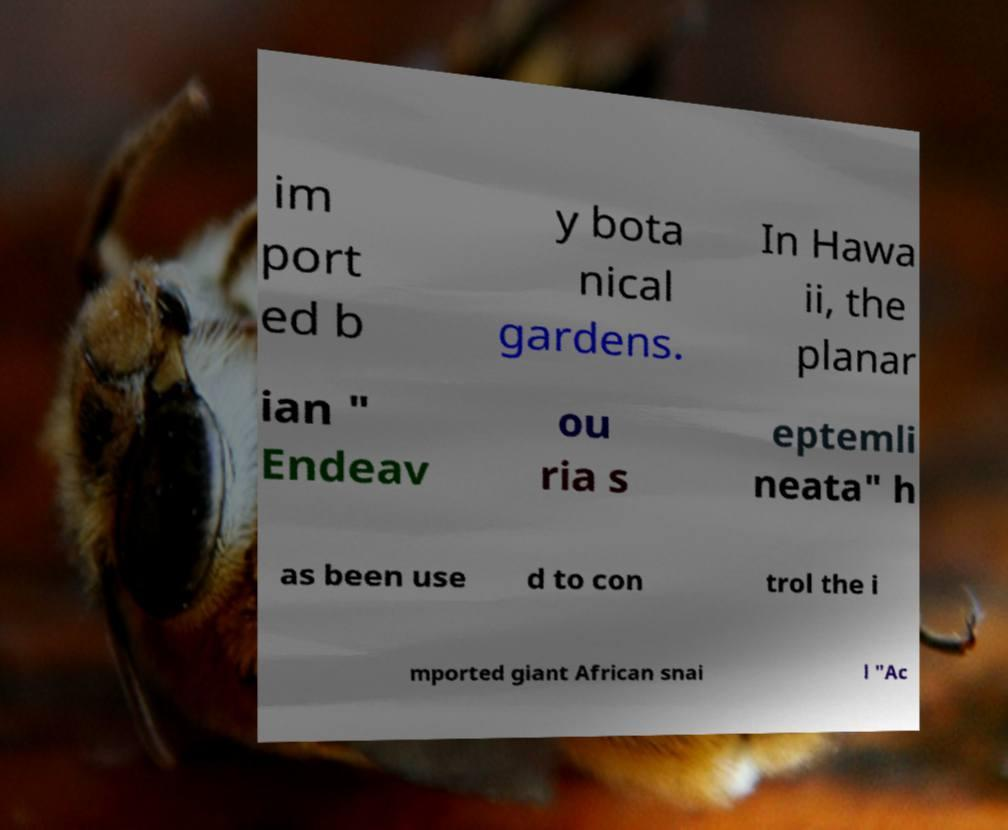Could you assist in decoding the text presented in this image and type it out clearly? im port ed b y bota nical gardens. In Hawa ii, the planar ian " Endeav ou ria s eptemli neata" h as been use d to con trol the i mported giant African snai l "Ac 